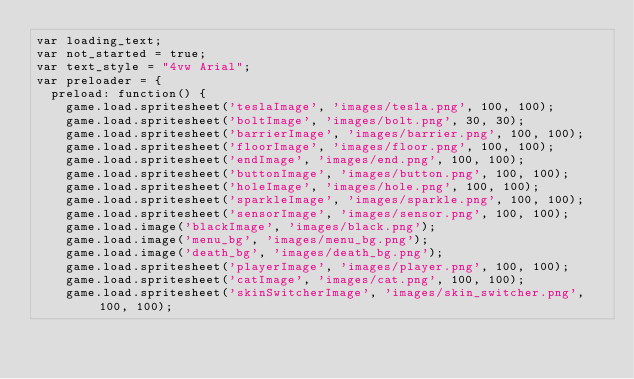<code> <loc_0><loc_0><loc_500><loc_500><_JavaScript_>var loading_text;
var not_started = true;
var text_style = "4vw Arial";
var preloader = {
  preload: function() {
    game.load.spritesheet('teslaImage', 'images/tesla.png', 100, 100);
    game.load.spritesheet('boltImage', 'images/bolt.png', 30, 30);
    game.load.spritesheet('barrierImage', 'images/barrier.png', 100, 100);
    game.load.spritesheet('floorImage', 'images/floor.png', 100, 100);
    game.load.spritesheet('endImage', 'images/end.png', 100, 100);
    game.load.spritesheet('buttonImage', 'images/button.png', 100, 100);
    game.load.spritesheet('holeImage', 'images/hole.png', 100, 100);
    game.load.spritesheet('sparkleImage', 'images/sparkle.png', 100, 100);
    game.load.spritesheet('sensorImage', 'images/sensor.png', 100, 100);
    game.load.image('blackImage', 'images/black.png');
    game.load.image('menu_bg', 'images/menu_bg.png');
    game.load.image('death_bg', 'images/death_bg.png');
    game.load.spritesheet('playerImage', 'images/player.png', 100, 100);
    game.load.spritesheet('catImage', 'images/cat.png', 100, 100);
    game.load.spritesheet('skinSwitcherImage', 'images/skin_switcher.png', 100, 100);
</code> 